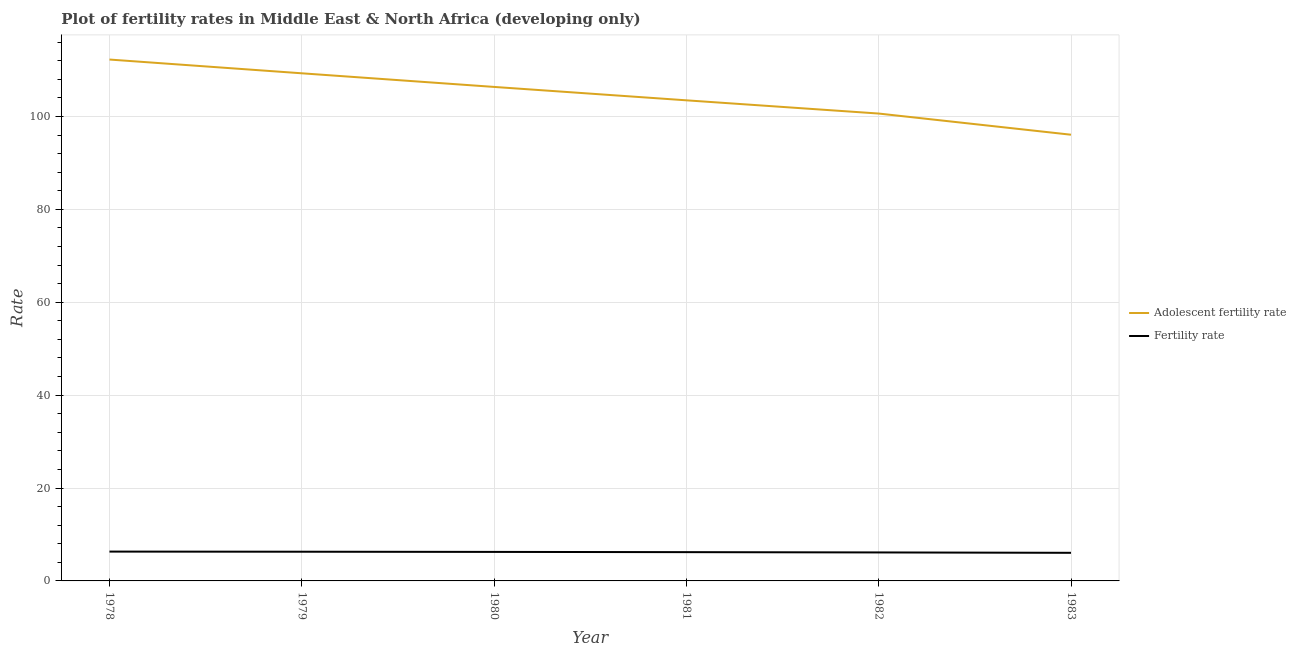How many different coloured lines are there?
Make the answer very short. 2. Does the line corresponding to fertility rate intersect with the line corresponding to adolescent fertility rate?
Your response must be concise. No. Is the number of lines equal to the number of legend labels?
Your response must be concise. Yes. What is the adolescent fertility rate in 1981?
Your response must be concise. 103.47. Across all years, what is the maximum adolescent fertility rate?
Your response must be concise. 112.25. Across all years, what is the minimum adolescent fertility rate?
Your answer should be compact. 96.07. In which year was the fertility rate maximum?
Make the answer very short. 1978. In which year was the fertility rate minimum?
Offer a very short reply. 1983. What is the total adolescent fertility rate in the graph?
Provide a short and direct response. 628.08. What is the difference between the fertility rate in 1979 and that in 1980?
Ensure brevity in your answer.  0.04. What is the difference between the fertility rate in 1980 and the adolescent fertility rate in 1983?
Give a very brief answer. -89.82. What is the average adolescent fertility rate per year?
Ensure brevity in your answer.  104.68. In the year 1983, what is the difference between the adolescent fertility rate and fertility rate?
Provide a succinct answer. 90.02. In how many years, is the fertility rate greater than 16?
Offer a very short reply. 0. What is the ratio of the adolescent fertility rate in 1978 to that in 1983?
Provide a succinct answer. 1.17. Is the fertility rate in 1979 less than that in 1980?
Provide a short and direct response. No. Is the difference between the fertility rate in 1980 and 1982 greater than the difference between the adolescent fertility rate in 1980 and 1982?
Give a very brief answer. No. What is the difference between the highest and the second highest fertility rate?
Keep it short and to the point. 0.03. What is the difference between the highest and the lowest fertility rate?
Give a very brief answer. 0.26. Does the adolescent fertility rate monotonically increase over the years?
Make the answer very short. No. Is the adolescent fertility rate strictly greater than the fertility rate over the years?
Ensure brevity in your answer.  Yes. How many years are there in the graph?
Provide a succinct answer. 6. Does the graph contain any zero values?
Your answer should be compact. No. Does the graph contain grids?
Give a very brief answer. Yes. Where does the legend appear in the graph?
Provide a short and direct response. Center right. How are the legend labels stacked?
Keep it short and to the point. Vertical. What is the title of the graph?
Make the answer very short. Plot of fertility rates in Middle East & North Africa (developing only). What is the label or title of the Y-axis?
Your answer should be very brief. Rate. What is the Rate in Adolescent fertility rate in 1978?
Give a very brief answer. 112.25. What is the Rate of Fertility rate in 1978?
Offer a very short reply. 6.32. What is the Rate of Adolescent fertility rate in 1979?
Give a very brief answer. 109.29. What is the Rate of Fertility rate in 1979?
Your response must be concise. 6.29. What is the Rate of Adolescent fertility rate in 1980?
Offer a very short reply. 106.36. What is the Rate in Fertility rate in 1980?
Your answer should be very brief. 6.25. What is the Rate of Adolescent fertility rate in 1981?
Your answer should be very brief. 103.47. What is the Rate of Fertility rate in 1981?
Your response must be concise. 6.2. What is the Rate of Adolescent fertility rate in 1982?
Your response must be concise. 100.63. What is the Rate in Fertility rate in 1982?
Ensure brevity in your answer.  6.13. What is the Rate in Adolescent fertility rate in 1983?
Provide a short and direct response. 96.07. What is the Rate of Fertility rate in 1983?
Offer a very short reply. 6.05. Across all years, what is the maximum Rate of Adolescent fertility rate?
Your answer should be compact. 112.25. Across all years, what is the maximum Rate in Fertility rate?
Your answer should be compact. 6.32. Across all years, what is the minimum Rate of Adolescent fertility rate?
Provide a succinct answer. 96.07. Across all years, what is the minimum Rate of Fertility rate?
Provide a succinct answer. 6.05. What is the total Rate of Adolescent fertility rate in the graph?
Offer a very short reply. 628.08. What is the total Rate of Fertility rate in the graph?
Ensure brevity in your answer.  37.23. What is the difference between the Rate of Adolescent fertility rate in 1978 and that in 1979?
Keep it short and to the point. 2.96. What is the difference between the Rate of Fertility rate in 1978 and that in 1979?
Offer a terse response. 0.03. What is the difference between the Rate of Adolescent fertility rate in 1978 and that in 1980?
Make the answer very short. 5.89. What is the difference between the Rate of Fertility rate in 1978 and that in 1980?
Make the answer very short. 0.07. What is the difference between the Rate of Adolescent fertility rate in 1978 and that in 1981?
Provide a short and direct response. 8.78. What is the difference between the Rate in Fertility rate in 1978 and that in 1981?
Keep it short and to the point. 0.12. What is the difference between the Rate in Adolescent fertility rate in 1978 and that in 1982?
Offer a very short reply. 11.63. What is the difference between the Rate in Fertility rate in 1978 and that in 1982?
Your answer should be compact. 0.18. What is the difference between the Rate of Adolescent fertility rate in 1978 and that in 1983?
Offer a very short reply. 16.19. What is the difference between the Rate of Fertility rate in 1978 and that in 1983?
Offer a terse response. 0.26. What is the difference between the Rate of Adolescent fertility rate in 1979 and that in 1980?
Make the answer very short. 2.93. What is the difference between the Rate of Fertility rate in 1979 and that in 1980?
Offer a terse response. 0.04. What is the difference between the Rate of Adolescent fertility rate in 1979 and that in 1981?
Keep it short and to the point. 5.82. What is the difference between the Rate of Fertility rate in 1979 and that in 1981?
Provide a short and direct response. 0.09. What is the difference between the Rate in Adolescent fertility rate in 1979 and that in 1982?
Your response must be concise. 8.67. What is the difference between the Rate of Fertility rate in 1979 and that in 1982?
Your answer should be very brief. 0.15. What is the difference between the Rate of Adolescent fertility rate in 1979 and that in 1983?
Ensure brevity in your answer.  13.22. What is the difference between the Rate in Fertility rate in 1979 and that in 1983?
Offer a very short reply. 0.23. What is the difference between the Rate in Adolescent fertility rate in 1980 and that in 1981?
Make the answer very short. 2.89. What is the difference between the Rate of Fertility rate in 1980 and that in 1981?
Provide a short and direct response. 0.05. What is the difference between the Rate of Adolescent fertility rate in 1980 and that in 1982?
Offer a terse response. 5.73. What is the difference between the Rate in Fertility rate in 1980 and that in 1982?
Your answer should be very brief. 0.12. What is the difference between the Rate in Adolescent fertility rate in 1980 and that in 1983?
Provide a succinct answer. 10.29. What is the difference between the Rate of Fertility rate in 1980 and that in 1983?
Keep it short and to the point. 0.2. What is the difference between the Rate in Adolescent fertility rate in 1981 and that in 1982?
Give a very brief answer. 2.85. What is the difference between the Rate of Fertility rate in 1981 and that in 1982?
Keep it short and to the point. 0.07. What is the difference between the Rate of Adolescent fertility rate in 1981 and that in 1983?
Your answer should be compact. 7.41. What is the difference between the Rate of Fertility rate in 1981 and that in 1983?
Your answer should be compact. 0.15. What is the difference between the Rate of Adolescent fertility rate in 1982 and that in 1983?
Offer a very short reply. 4.56. What is the difference between the Rate in Fertility rate in 1982 and that in 1983?
Your response must be concise. 0.08. What is the difference between the Rate of Adolescent fertility rate in 1978 and the Rate of Fertility rate in 1979?
Give a very brief answer. 105.97. What is the difference between the Rate of Adolescent fertility rate in 1978 and the Rate of Fertility rate in 1980?
Provide a short and direct response. 106.01. What is the difference between the Rate of Adolescent fertility rate in 1978 and the Rate of Fertility rate in 1981?
Ensure brevity in your answer.  106.06. What is the difference between the Rate in Adolescent fertility rate in 1978 and the Rate in Fertility rate in 1982?
Provide a short and direct response. 106.12. What is the difference between the Rate in Adolescent fertility rate in 1978 and the Rate in Fertility rate in 1983?
Offer a very short reply. 106.2. What is the difference between the Rate of Adolescent fertility rate in 1979 and the Rate of Fertility rate in 1980?
Make the answer very short. 103.05. What is the difference between the Rate in Adolescent fertility rate in 1979 and the Rate in Fertility rate in 1981?
Keep it short and to the point. 103.1. What is the difference between the Rate of Adolescent fertility rate in 1979 and the Rate of Fertility rate in 1982?
Provide a short and direct response. 103.16. What is the difference between the Rate in Adolescent fertility rate in 1979 and the Rate in Fertility rate in 1983?
Give a very brief answer. 103.24. What is the difference between the Rate in Adolescent fertility rate in 1980 and the Rate in Fertility rate in 1981?
Offer a terse response. 100.16. What is the difference between the Rate in Adolescent fertility rate in 1980 and the Rate in Fertility rate in 1982?
Give a very brief answer. 100.23. What is the difference between the Rate in Adolescent fertility rate in 1980 and the Rate in Fertility rate in 1983?
Offer a terse response. 100.31. What is the difference between the Rate of Adolescent fertility rate in 1981 and the Rate of Fertility rate in 1982?
Provide a succinct answer. 97.34. What is the difference between the Rate in Adolescent fertility rate in 1981 and the Rate in Fertility rate in 1983?
Provide a succinct answer. 97.42. What is the difference between the Rate of Adolescent fertility rate in 1982 and the Rate of Fertility rate in 1983?
Your response must be concise. 94.58. What is the average Rate of Adolescent fertility rate per year?
Make the answer very short. 104.68. What is the average Rate of Fertility rate per year?
Make the answer very short. 6.21. In the year 1978, what is the difference between the Rate of Adolescent fertility rate and Rate of Fertility rate?
Provide a succinct answer. 105.94. In the year 1979, what is the difference between the Rate in Adolescent fertility rate and Rate in Fertility rate?
Provide a short and direct response. 103.01. In the year 1980, what is the difference between the Rate in Adolescent fertility rate and Rate in Fertility rate?
Provide a short and direct response. 100.11. In the year 1981, what is the difference between the Rate in Adolescent fertility rate and Rate in Fertility rate?
Your answer should be very brief. 97.28. In the year 1982, what is the difference between the Rate in Adolescent fertility rate and Rate in Fertility rate?
Offer a very short reply. 94.49. In the year 1983, what is the difference between the Rate of Adolescent fertility rate and Rate of Fertility rate?
Keep it short and to the point. 90.02. What is the ratio of the Rate of Adolescent fertility rate in 1978 to that in 1979?
Your answer should be compact. 1.03. What is the ratio of the Rate of Adolescent fertility rate in 1978 to that in 1980?
Ensure brevity in your answer.  1.06. What is the ratio of the Rate of Fertility rate in 1978 to that in 1980?
Provide a succinct answer. 1.01. What is the ratio of the Rate of Adolescent fertility rate in 1978 to that in 1981?
Your answer should be very brief. 1.08. What is the ratio of the Rate in Fertility rate in 1978 to that in 1981?
Offer a terse response. 1.02. What is the ratio of the Rate in Adolescent fertility rate in 1978 to that in 1982?
Your response must be concise. 1.12. What is the ratio of the Rate of Fertility rate in 1978 to that in 1982?
Offer a very short reply. 1.03. What is the ratio of the Rate of Adolescent fertility rate in 1978 to that in 1983?
Your answer should be compact. 1.17. What is the ratio of the Rate of Fertility rate in 1978 to that in 1983?
Your answer should be compact. 1.04. What is the ratio of the Rate of Adolescent fertility rate in 1979 to that in 1980?
Your response must be concise. 1.03. What is the ratio of the Rate of Adolescent fertility rate in 1979 to that in 1981?
Give a very brief answer. 1.06. What is the ratio of the Rate in Fertility rate in 1979 to that in 1981?
Keep it short and to the point. 1.01. What is the ratio of the Rate in Adolescent fertility rate in 1979 to that in 1982?
Your answer should be very brief. 1.09. What is the ratio of the Rate in Fertility rate in 1979 to that in 1982?
Provide a succinct answer. 1.03. What is the ratio of the Rate of Adolescent fertility rate in 1979 to that in 1983?
Offer a very short reply. 1.14. What is the ratio of the Rate of Fertility rate in 1979 to that in 1983?
Your answer should be compact. 1.04. What is the ratio of the Rate in Adolescent fertility rate in 1980 to that in 1981?
Your answer should be compact. 1.03. What is the ratio of the Rate in Adolescent fertility rate in 1980 to that in 1982?
Make the answer very short. 1.06. What is the ratio of the Rate in Fertility rate in 1980 to that in 1982?
Your answer should be very brief. 1.02. What is the ratio of the Rate in Adolescent fertility rate in 1980 to that in 1983?
Ensure brevity in your answer.  1.11. What is the ratio of the Rate in Fertility rate in 1980 to that in 1983?
Your answer should be very brief. 1.03. What is the ratio of the Rate of Adolescent fertility rate in 1981 to that in 1982?
Your answer should be very brief. 1.03. What is the ratio of the Rate in Fertility rate in 1981 to that in 1982?
Ensure brevity in your answer.  1.01. What is the ratio of the Rate in Adolescent fertility rate in 1981 to that in 1983?
Provide a succinct answer. 1.08. What is the ratio of the Rate in Fertility rate in 1981 to that in 1983?
Keep it short and to the point. 1.02. What is the ratio of the Rate of Adolescent fertility rate in 1982 to that in 1983?
Give a very brief answer. 1.05. What is the ratio of the Rate in Fertility rate in 1982 to that in 1983?
Your response must be concise. 1.01. What is the difference between the highest and the second highest Rate in Adolescent fertility rate?
Offer a terse response. 2.96. What is the difference between the highest and the second highest Rate of Fertility rate?
Your answer should be compact. 0.03. What is the difference between the highest and the lowest Rate of Adolescent fertility rate?
Your answer should be very brief. 16.19. What is the difference between the highest and the lowest Rate in Fertility rate?
Give a very brief answer. 0.26. 